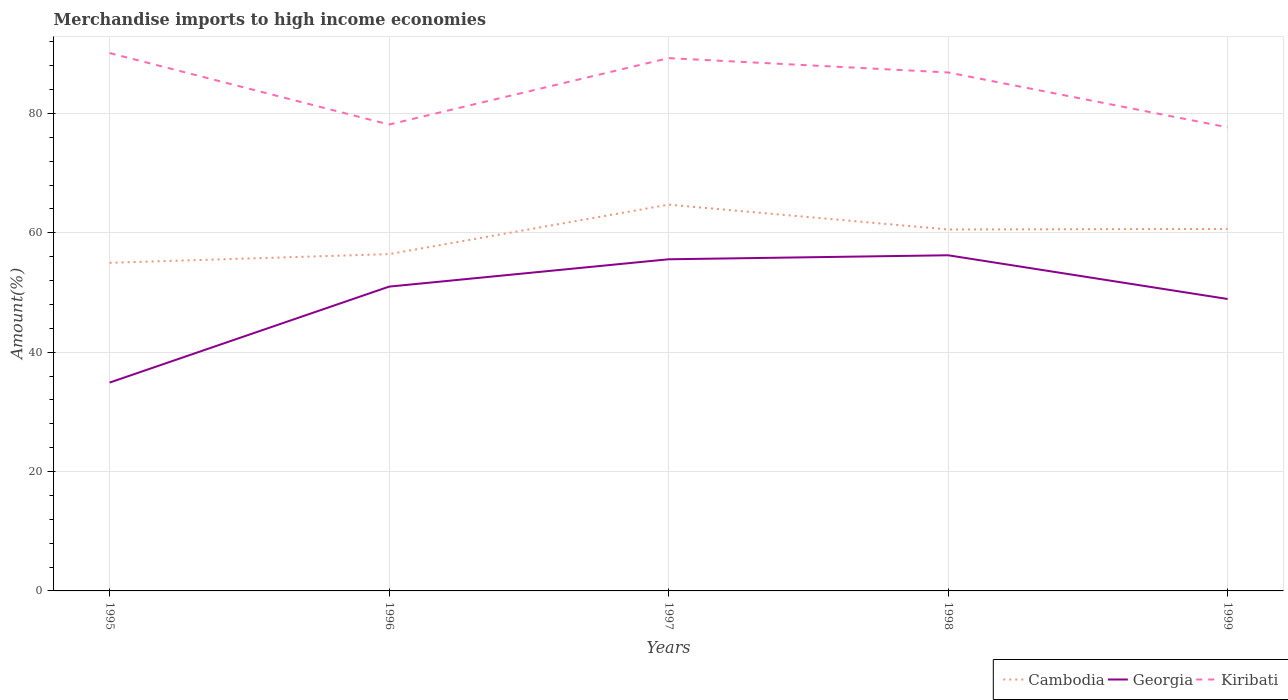Is the number of lines equal to the number of legend labels?
Offer a very short reply. Yes. Across all years, what is the maximum percentage of amount earned from merchandise imports in Georgia?
Your answer should be very brief. 34.9. In which year was the percentage of amount earned from merchandise imports in Georgia maximum?
Give a very brief answer. 1995. What is the total percentage of amount earned from merchandise imports in Cambodia in the graph?
Keep it short and to the point. -1.45. What is the difference between the highest and the second highest percentage of amount earned from merchandise imports in Cambodia?
Give a very brief answer. 9.74. What is the difference between the highest and the lowest percentage of amount earned from merchandise imports in Kiribati?
Your answer should be compact. 3. Is the percentage of amount earned from merchandise imports in Georgia strictly greater than the percentage of amount earned from merchandise imports in Kiribati over the years?
Give a very brief answer. Yes. How many lines are there?
Offer a very short reply. 3. Does the graph contain grids?
Provide a succinct answer. Yes. What is the title of the graph?
Give a very brief answer. Merchandise imports to high income economies. What is the label or title of the X-axis?
Your answer should be compact. Years. What is the label or title of the Y-axis?
Ensure brevity in your answer.  Amount(%). What is the Amount(%) in Cambodia in 1995?
Offer a very short reply. 54.97. What is the Amount(%) in Georgia in 1995?
Give a very brief answer. 34.9. What is the Amount(%) of Kiribati in 1995?
Give a very brief answer. 90.11. What is the Amount(%) in Cambodia in 1996?
Make the answer very short. 56.43. What is the Amount(%) of Georgia in 1996?
Offer a terse response. 50.98. What is the Amount(%) of Kiribati in 1996?
Offer a terse response. 78.13. What is the Amount(%) of Cambodia in 1997?
Provide a succinct answer. 64.71. What is the Amount(%) in Georgia in 1997?
Keep it short and to the point. 55.56. What is the Amount(%) of Kiribati in 1997?
Offer a terse response. 89.26. What is the Amount(%) of Cambodia in 1998?
Your response must be concise. 60.55. What is the Amount(%) of Georgia in 1998?
Your response must be concise. 56.23. What is the Amount(%) of Kiribati in 1998?
Make the answer very short. 86.86. What is the Amount(%) of Cambodia in 1999?
Keep it short and to the point. 60.64. What is the Amount(%) of Georgia in 1999?
Keep it short and to the point. 48.91. What is the Amount(%) of Kiribati in 1999?
Provide a succinct answer. 77.67. Across all years, what is the maximum Amount(%) of Cambodia?
Make the answer very short. 64.71. Across all years, what is the maximum Amount(%) of Georgia?
Make the answer very short. 56.23. Across all years, what is the maximum Amount(%) of Kiribati?
Your answer should be very brief. 90.11. Across all years, what is the minimum Amount(%) in Cambodia?
Your response must be concise. 54.97. Across all years, what is the minimum Amount(%) of Georgia?
Offer a very short reply. 34.9. Across all years, what is the minimum Amount(%) in Kiribati?
Provide a succinct answer. 77.67. What is the total Amount(%) in Cambodia in the graph?
Provide a short and direct response. 297.31. What is the total Amount(%) of Georgia in the graph?
Your answer should be compact. 246.58. What is the total Amount(%) of Kiribati in the graph?
Your answer should be very brief. 422.04. What is the difference between the Amount(%) in Cambodia in 1995 and that in 1996?
Keep it short and to the point. -1.45. What is the difference between the Amount(%) of Georgia in 1995 and that in 1996?
Your answer should be very brief. -16.08. What is the difference between the Amount(%) of Kiribati in 1995 and that in 1996?
Provide a short and direct response. 11.97. What is the difference between the Amount(%) of Cambodia in 1995 and that in 1997?
Make the answer very short. -9.74. What is the difference between the Amount(%) of Georgia in 1995 and that in 1997?
Your answer should be very brief. -20.66. What is the difference between the Amount(%) of Kiribati in 1995 and that in 1997?
Provide a succinct answer. 0.85. What is the difference between the Amount(%) of Cambodia in 1995 and that in 1998?
Provide a succinct answer. -5.58. What is the difference between the Amount(%) in Georgia in 1995 and that in 1998?
Provide a short and direct response. -21.33. What is the difference between the Amount(%) in Kiribati in 1995 and that in 1998?
Ensure brevity in your answer.  3.25. What is the difference between the Amount(%) in Cambodia in 1995 and that in 1999?
Offer a terse response. -5.67. What is the difference between the Amount(%) of Georgia in 1995 and that in 1999?
Keep it short and to the point. -14. What is the difference between the Amount(%) in Kiribati in 1995 and that in 1999?
Your answer should be compact. 12.44. What is the difference between the Amount(%) in Cambodia in 1996 and that in 1997?
Provide a short and direct response. -8.29. What is the difference between the Amount(%) of Georgia in 1996 and that in 1997?
Offer a very short reply. -4.58. What is the difference between the Amount(%) of Kiribati in 1996 and that in 1997?
Make the answer very short. -11.13. What is the difference between the Amount(%) in Cambodia in 1996 and that in 1998?
Keep it short and to the point. -4.13. What is the difference between the Amount(%) in Georgia in 1996 and that in 1998?
Keep it short and to the point. -5.25. What is the difference between the Amount(%) of Kiribati in 1996 and that in 1998?
Offer a terse response. -8.72. What is the difference between the Amount(%) in Cambodia in 1996 and that in 1999?
Your answer should be compact. -4.22. What is the difference between the Amount(%) in Georgia in 1996 and that in 1999?
Your response must be concise. 2.07. What is the difference between the Amount(%) in Kiribati in 1996 and that in 1999?
Offer a terse response. 0.46. What is the difference between the Amount(%) in Cambodia in 1997 and that in 1998?
Offer a terse response. 4.16. What is the difference between the Amount(%) in Georgia in 1997 and that in 1998?
Your response must be concise. -0.67. What is the difference between the Amount(%) in Kiribati in 1997 and that in 1998?
Your answer should be very brief. 2.4. What is the difference between the Amount(%) in Cambodia in 1997 and that in 1999?
Ensure brevity in your answer.  4.07. What is the difference between the Amount(%) in Georgia in 1997 and that in 1999?
Make the answer very short. 6.65. What is the difference between the Amount(%) of Kiribati in 1997 and that in 1999?
Keep it short and to the point. 11.59. What is the difference between the Amount(%) of Cambodia in 1998 and that in 1999?
Your answer should be very brief. -0.09. What is the difference between the Amount(%) of Georgia in 1998 and that in 1999?
Ensure brevity in your answer.  7.33. What is the difference between the Amount(%) of Kiribati in 1998 and that in 1999?
Give a very brief answer. 9.19. What is the difference between the Amount(%) in Cambodia in 1995 and the Amount(%) in Georgia in 1996?
Provide a short and direct response. 3.99. What is the difference between the Amount(%) in Cambodia in 1995 and the Amount(%) in Kiribati in 1996?
Your answer should be very brief. -23.16. What is the difference between the Amount(%) in Georgia in 1995 and the Amount(%) in Kiribati in 1996?
Make the answer very short. -43.23. What is the difference between the Amount(%) of Cambodia in 1995 and the Amount(%) of Georgia in 1997?
Your answer should be very brief. -0.59. What is the difference between the Amount(%) of Cambodia in 1995 and the Amount(%) of Kiribati in 1997?
Offer a very short reply. -34.29. What is the difference between the Amount(%) in Georgia in 1995 and the Amount(%) in Kiribati in 1997?
Provide a short and direct response. -54.36. What is the difference between the Amount(%) in Cambodia in 1995 and the Amount(%) in Georgia in 1998?
Provide a succinct answer. -1.26. What is the difference between the Amount(%) in Cambodia in 1995 and the Amount(%) in Kiribati in 1998?
Your answer should be compact. -31.89. What is the difference between the Amount(%) in Georgia in 1995 and the Amount(%) in Kiribati in 1998?
Offer a terse response. -51.96. What is the difference between the Amount(%) in Cambodia in 1995 and the Amount(%) in Georgia in 1999?
Make the answer very short. 6.06. What is the difference between the Amount(%) in Cambodia in 1995 and the Amount(%) in Kiribati in 1999?
Ensure brevity in your answer.  -22.7. What is the difference between the Amount(%) of Georgia in 1995 and the Amount(%) of Kiribati in 1999?
Provide a succinct answer. -42.77. What is the difference between the Amount(%) of Cambodia in 1996 and the Amount(%) of Georgia in 1997?
Provide a short and direct response. 0.87. What is the difference between the Amount(%) of Cambodia in 1996 and the Amount(%) of Kiribati in 1997?
Keep it short and to the point. -32.83. What is the difference between the Amount(%) in Georgia in 1996 and the Amount(%) in Kiribati in 1997?
Give a very brief answer. -38.28. What is the difference between the Amount(%) in Cambodia in 1996 and the Amount(%) in Georgia in 1998?
Your answer should be compact. 0.19. What is the difference between the Amount(%) in Cambodia in 1996 and the Amount(%) in Kiribati in 1998?
Make the answer very short. -30.43. What is the difference between the Amount(%) in Georgia in 1996 and the Amount(%) in Kiribati in 1998?
Your answer should be compact. -35.88. What is the difference between the Amount(%) in Cambodia in 1996 and the Amount(%) in Georgia in 1999?
Your answer should be very brief. 7.52. What is the difference between the Amount(%) in Cambodia in 1996 and the Amount(%) in Kiribati in 1999?
Offer a terse response. -21.24. What is the difference between the Amount(%) in Georgia in 1996 and the Amount(%) in Kiribati in 1999?
Make the answer very short. -26.69. What is the difference between the Amount(%) of Cambodia in 1997 and the Amount(%) of Georgia in 1998?
Your response must be concise. 8.48. What is the difference between the Amount(%) of Cambodia in 1997 and the Amount(%) of Kiribati in 1998?
Make the answer very short. -22.15. What is the difference between the Amount(%) in Georgia in 1997 and the Amount(%) in Kiribati in 1998?
Your answer should be very brief. -31.3. What is the difference between the Amount(%) in Cambodia in 1997 and the Amount(%) in Georgia in 1999?
Give a very brief answer. 15.81. What is the difference between the Amount(%) in Cambodia in 1997 and the Amount(%) in Kiribati in 1999?
Your response must be concise. -12.96. What is the difference between the Amount(%) in Georgia in 1997 and the Amount(%) in Kiribati in 1999?
Make the answer very short. -22.11. What is the difference between the Amount(%) of Cambodia in 1998 and the Amount(%) of Georgia in 1999?
Provide a short and direct response. 11.65. What is the difference between the Amount(%) in Cambodia in 1998 and the Amount(%) in Kiribati in 1999?
Offer a very short reply. -17.12. What is the difference between the Amount(%) of Georgia in 1998 and the Amount(%) of Kiribati in 1999?
Your answer should be very brief. -21.44. What is the average Amount(%) of Cambodia per year?
Your answer should be very brief. 59.46. What is the average Amount(%) in Georgia per year?
Offer a very short reply. 49.32. What is the average Amount(%) of Kiribati per year?
Provide a succinct answer. 84.41. In the year 1995, what is the difference between the Amount(%) of Cambodia and Amount(%) of Georgia?
Offer a very short reply. 20.07. In the year 1995, what is the difference between the Amount(%) of Cambodia and Amount(%) of Kiribati?
Provide a succinct answer. -35.14. In the year 1995, what is the difference between the Amount(%) in Georgia and Amount(%) in Kiribati?
Make the answer very short. -55.21. In the year 1996, what is the difference between the Amount(%) of Cambodia and Amount(%) of Georgia?
Give a very brief answer. 5.45. In the year 1996, what is the difference between the Amount(%) in Cambodia and Amount(%) in Kiribati?
Offer a terse response. -21.71. In the year 1996, what is the difference between the Amount(%) of Georgia and Amount(%) of Kiribati?
Provide a short and direct response. -27.15. In the year 1997, what is the difference between the Amount(%) in Cambodia and Amount(%) in Georgia?
Your answer should be compact. 9.15. In the year 1997, what is the difference between the Amount(%) in Cambodia and Amount(%) in Kiribati?
Your response must be concise. -24.55. In the year 1997, what is the difference between the Amount(%) of Georgia and Amount(%) of Kiribati?
Your response must be concise. -33.7. In the year 1998, what is the difference between the Amount(%) in Cambodia and Amount(%) in Georgia?
Your response must be concise. 4.32. In the year 1998, what is the difference between the Amount(%) in Cambodia and Amount(%) in Kiribati?
Offer a terse response. -26.3. In the year 1998, what is the difference between the Amount(%) of Georgia and Amount(%) of Kiribati?
Offer a very short reply. -30.63. In the year 1999, what is the difference between the Amount(%) of Cambodia and Amount(%) of Georgia?
Keep it short and to the point. 11.74. In the year 1999, what is the difference between the Amount(%) in Cambodia and Amount(%) in Kiribati?
Your response must be concise. -17.03. In the year 1999, what is the difference between the Amount(%) of Georgia and Amount(%) of Kiribati?
Offer a terse response. -28.76. What is the ratio of the Amount(%) of Cambodia in 1995 to that in 1996?
Give a very brief answer. 0.97. What is the ratio of the Amount(%) of Georgia in 1995 to that in 1996?
Give a very brief answer. 0.68. What is the ratio of the Amount(%) of Kiribati in 1995 to that in 1996?
Your response must be concise. 1.15. What is the ratio of the Amount(%) of Cambodia in 1995 to that in 1997?
Provide a short and direct response. 0.85. What is the ratio of the Amount(%) in Georgia in 1995 to that in 1997?
Your answer should be compact. 0.63. What is the ratio of the Amount(%) in Kiribati in 1995 to that in 1997?
Your answer should be very brief. 1.01. What is the ratio of the Amount(%) of Cambodia in 1995 to that in 1998?
Give a very brief answer. 0.91. What is the ratio of the Amount(%) in Georgia in 1995 to that in 1998?
Your answer should be compact. 0.62. What is the ratio of the Amount(%) in Kiribati in 1995 to that in 1998?
Offer a terse response. 1.04. What is the ratio of the Amount(%) in Cambodia in 1995 to that in 1999?
Your answer should be compact. 0.91. What is the ratio of the Amount(%) in Georgia in 1995 to that in 1999?
Provide a short and direct response. 0.71. What is the ratio of the Amount(%) in Kiribati in 1995 to that in 1999?
Offer a terse response. 1.16. What is the ratio of the Amount(%) in Cambodia in 1996 to that in 1997?
Offer a terse response. 0.87. What is the ratio of the Amount(%) of Georgia in 1996 to that in 1997?
Keep it short and to the point. 0.92. What is the ratio of the Amount(%) in Kiribati in 1996 to that in 1997?
Provide a short and direct response. 0.88. What is the ratio of the Amount(%) of Cambodia in 1996 to that in 1998?
Keep it short and to the point. 0.93. What is the ratio of the Amount(%) of Georgia in 1996 to that in 1998?
Your answer should be very brief. 0.91. What is the ratio of the Amount(%) in Kiribati in 1996 to that in 1998?
Your response must be concise. 0.9. What is the ratio of the Amount(%) in Cambodia in 1996 to that in 1999?
Provide a succinct answer. 0.93. What is the ratio of the Amount(%) of Georgia in 1996 to that in 1999?
Ensure brevity in your answer.  1.04. What is the ratio of the Amount(%) of Kiribati in 1996 to that in 1999?
Give a very brief answer. 1.01. What is the ratio of the Amount(%) in Cambodia in 1997 to that in 1998?
Your response must be concise. 1.07. What is the ratio of the Amount(%) in Georgia in 1997 to that in 1998?
Provide a short and direct response. 0.99. What is the ratio of the Amount(%) of Kiribati in 1997 to that in 1998?
Provide a succinct answer. 1.03. What is the ratio of the Amount(%) in Cambodia in 1997 to that in 1999?
Provide a short and direct response. 1.07. What is the ratio of the Amount(%) in Georgia in 1997 to that in 1999?
Make the answer very short. 1.14. What is the ratio of the Amount(%) in Kiribati in 1997 to that in 1999?
Offer a very short reply. 1.15. What is the ratio of the Amount(%) in Cambodia in 1998 to that in 1999?
Provide a succinct answer. 1. What is the ratio of the Amount(%) of Georgia in 1998 to that in 1999?
Offer a very short reply. 1.15. What is the ratio of the Amount(%) in Kiribati in 1998 to that in 1999?
Offer a terse response. 1.12. What is the difference between the highest and the second highest Amount(%) of Cambodia?
Offer a terse response. 4.07. What is the difference between the highest and the second highest Amount(%) of Georgia?
Your answer should be very brief. 0.67. What is the difference between the highest and the second highest Amount(%) in Kiribati?
Your response must be concise. 0.85. What is the difference between the highest and the lowest Amount(%) in Cambodia?
Give a very brief answer. 9.74. What is the difference between the highest and the lowest Amount(%) of Georgia?
Keep it short and to the point. 21.33. What is the difference between the highest and the lowest Amount(%) in Kiribati?
Provide a short and direct response. 12.44. 